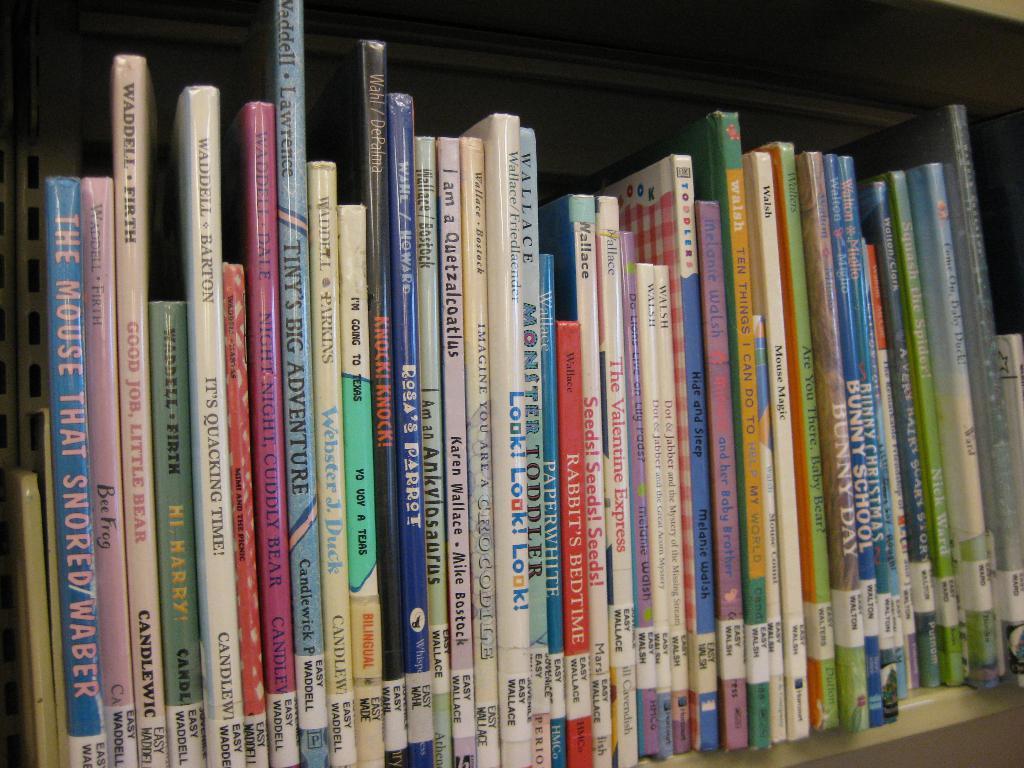What are the titles of the books?
Your response must be concise. Unanswerable. Who authored the pink book night night cuddly bear?
Provide a short and direct response. Waddell dale. 